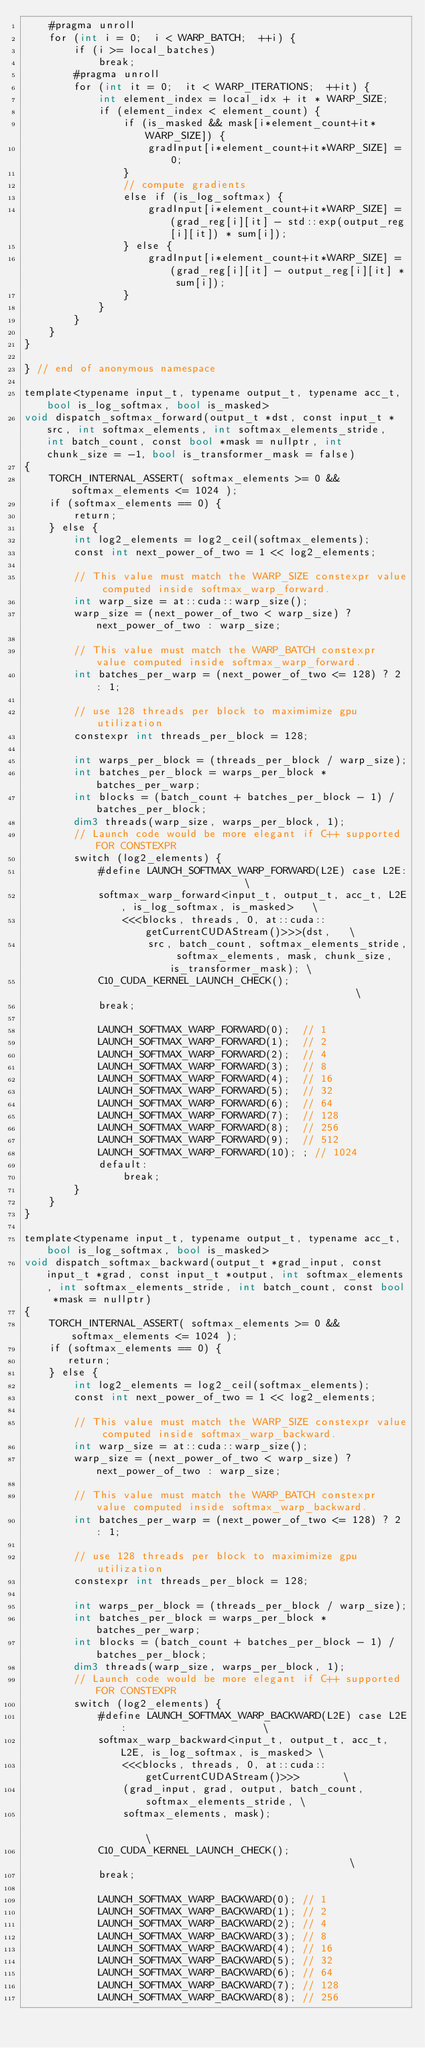Convert code to text. <code><loc_0><loc_0><loc_500><loc_500><_Cuda_>    #pragma unroll
    for (int i = 0;  i < WARP_BATCH;  ++i) {
        if (i >= local_batches)
            break;
        #pragma unroll
        for (int it = 0;  it < WARP_ITERATIONS;  ++it) {
            int element_index = local_idx + it * WARP_SIZE;
            if (element_index < element_count) {
                if (is_masked && mask[i*element_count+it*WARP_SIZE]) {
                    gradInput[i*element_count+it*WARP_SIZE] = 0;
                }
                // compute gradients
                else if (is_log_softmax) {
                    gradInput[i*element_count+it*WARP_SIZE] = (grad_reg[i][it] - std::exp(output_reg[i][it]) * sum[i]);
                } else {
                    gradInput[i*element_count+it*WARP_SIZE] = (grad_reg[i][it] - output_reg[i][it] * sum[i]);
                }
            }
        }
    }
}

} // end of anonymous namespace

template<typename input_t, typename output_t, typename acc_t, bool is_log_softmax, bool is_masked>
void dispatch_softmax_forward(output_t *dst, const input_t *src, int softmax_elements, int softmax_elements_stride, int batch_count, const bool *mask = nullptr, int chunk_size = -1, bool is_transformer_mask = false)
{
    TORCH_INTERNAL_ASSERT( softmax_elements >= 0 && softmax_elements <= 1024 );
    if (softmax_elements == 0) {
        return;
    } else {
        int log2_elements = log2_ceil(softmax_elements);
        const int next_power_of_two = 1 << log2_elements;

        // This value must match the WARP_SIZE constexpr value computed inside softmax_warp_forward.
        int warp_size = at::cuda::warp_size();
        warp_size = (next_power_of_two < warp_size) ? next_power_of_two : warp_size;

        // This value must match the WARP_BATCH constexpr value computed inside softmax_warp_forward.
        int batches_per_warp = (next_power_of_two <= 128) ? 2 : 1;

        // use 128 threads per block to maximimize gpu utilization
        constexpr int threads_per_block = 128;

        int warps_per_block = (threads_per_block / warp_size);
        int batches_per_block = warps_per_block * batches_per_warp;
        int blocks = (batch_count + batches_per_block - 1) / batches_per_block;
        dim3 threads(warp_size, warps_per_block, 1);
        // Launch code would be more elegant if C++ supported FOR CONSTEXPR
        switch (log2_elements) {
            #define LAUNCH_SOFTMAX_WARP_FORWARD(L2E) case L2E:                    \
            softmax_warp_forward<input_t, output_t, acc_t, L2E, is_log_softmax, is_masked>   \
                <<<blocks, threads, 0, at::cuda::getCurrentCUDAStream()>>>(dst,   \
                    src, batch_count, softmax_elements_stride, softmax_elements, mask, chunk_size, is_transformer_mask); \
            C10_CUDA_KERNEL_LAUNCH_CHECK();                                       \
            break;

            LAUNCH_SOFTMAX_WARP_FORWARD(0);  // 1
            LAUNCH_SOFTMAX_WARP_FORWARD(1);  // 2
            LAUNCH_SOFTMAX_WARP_FORWARD(2);  // 4
            LAUNCH_SOFTMAX_WARP_FORWARD(3);  // 8
            LAUNCH_SOFTMAX_WARP_FORWARD(4);  // 16
            LAUNCH_SOFTMAX_WARP_FORWARD(5);  // 32
            LAUNCH_SOFTMAX_WARP_FORWARD(6);  // 64
            LAUNCH_SOFTMAX_WARP_FORWARD(7);  // 128
            LAUNCH_SOFTMAX_WARP_FORWARD(8);  // 256
            LAUNCH_SOFTMAX_WARP_FORWARD(9);  // 512
            LAUNCH_SOFTMAX_WARP_FORWARD(10); ; // 1024
            default:
                break;
        }
    }
}

template<typename input_t, typename output_t, typename acc_t, bool is_log_softmax, bool is_masked>
void dispatch_softmax_backward(output_t *grad_input, const input_t *grad, const input_t *output, int softmax_elements, int softmax_elements_stride, int batch_count, const bool *mask = nullptr)
{
    TORCH_INTERNAL_ASSERT( softmax_elements >= 0 && softmax_elements <= 1024 );
    if (softmax_elements == 0) {
       return;
    } else {
        int log2_elements = log2_ceil(softmax_elements);
        const int next_power_of_two = 1 << log2_elements;

        // This value must match the WARP_SIZE constexpr value computed inside softmax_warp_backward.
        int warp_size = at::cuda::warp_size();
        warp_size = (next_power_of_two < warp_size) ? next_power_of_two : warp_size;

        // This value must match the WARP_BATCH constexpr value computed inside softmax_warp_backward.
        int batches_per_warp = (next_power_of_two <= 128) ? 2 : 1;

        // use 128 threads per block to maximimize gpu utilization
        constexpr int threads_per_block = 128;

        int warps_per_block = (threads_per_block / warp_size);
        int batches_per_block = warps_per_block * batches_per_warp;
        int blocks = (batch_count + batches_per_block - 1) / batches_per_block;
        dim3 threads(warp_size, warps_per_block, 1);
        // Launch code would be more elegant if C++ supported FOR CONSTEXPR
        switch (log2_elements) {
            #define LAUNCH_SOFTMAX_WARP_BACKWARD(L2E) case L2E:                      \
            softmax_warp_backward<input_t, output_t, acc_t, L2E, is_log_softmax, is_masked> \
                <<<blocks, threads, 0, at::cuda::getCurrentCUDAStream()>>>       \
                (grad_input, grad, output, batch_count, softmax_elements_stride, \
                softmax_elements, mask);                                              \
            C10_CUDA_KERNEL_LAUNCH_CHECK();                                      \
            break;

            LAUNCH_SOFTMAX_WARP_BACKWARD(0); // 1
            LAUNCH_SOFTMAX_WARP_BACKWARD(1); // 2
            LAUNCH_SOFTMAX_WARP_BACKWARD(2); // 4
            LAUNCH_SOFTMAX_WARP_BACKWARD(3); // 8
            LAUNCH_SOFTMAX_WARP_BACKWARD(4); // 16
            LAUNCH_SOFTMAX_WARP_BACKWARD(5); // 32
            LAUNCH_SOFTMAX_WARP_BACKWARD(6); // 64
            LAUNCH_SOFTMAX_WARP_BACKWARD(7); // 128
            LAUNCH_SOFTMAX_WARP_BACKWARD(8); // 256</code> 